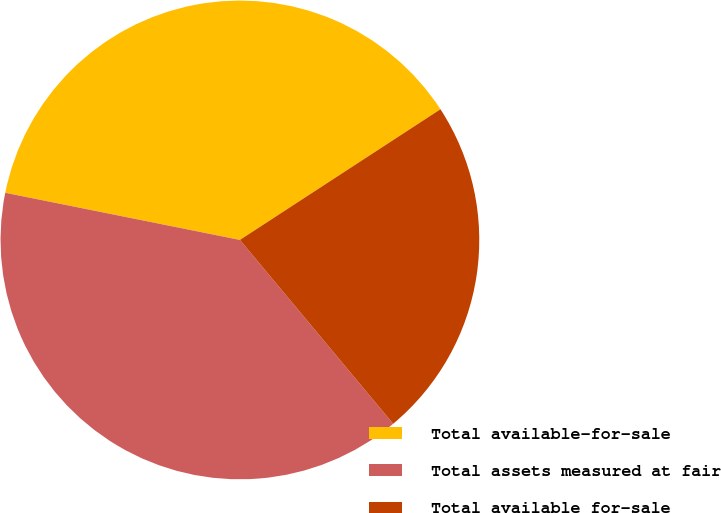Convert chart to OTSL. <chart><loc_0><loc_0><loc_500><loc_500><pie_chart><fcel>Total available-for-sale<fcel>Total assets measured at fair<fcel>Total available for-sale<nl><fcel>37.65%<fcel>39.21%<fcel>23.13%<nl></chart> 